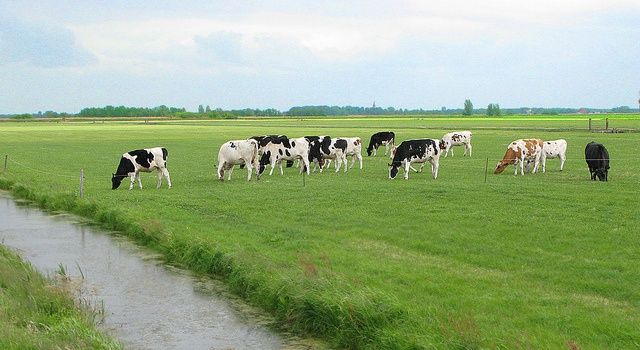Describe the objects in this image and their specific colors. I can see cow in lavender, black, lightgray, darkgray, and gray tones, cow in lavender, lightgray, black, tan, and darkgray tones, cow in lavender, black, lightgray, darkgray, and beige tones, cow in lavender, lightgray, darkgray, and tan tones, and cow in lavender, lightgray, brown, olive, and tan tones in this image. 